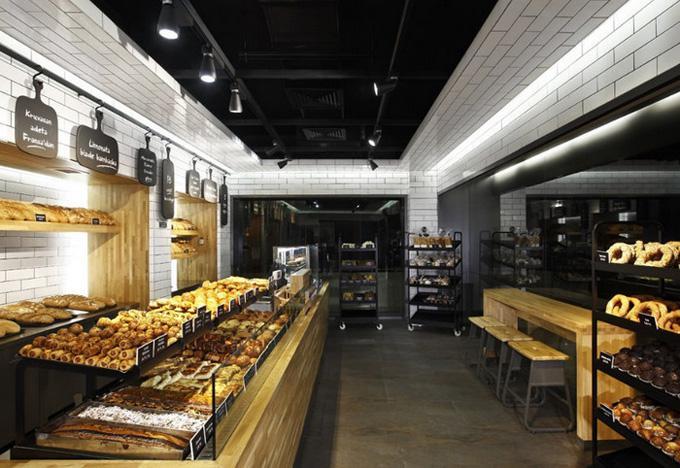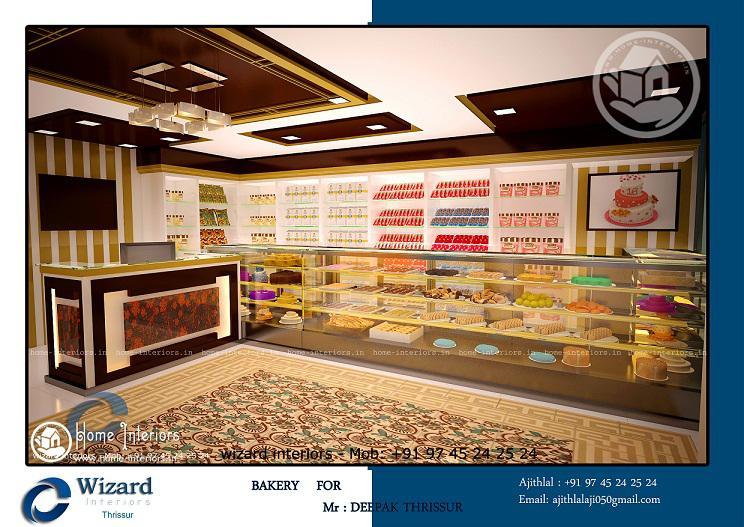The first image is the image on the left, the second image is the image on the right. Analyze the images presented: Is the assertion "The bakery in one image has white tile walls and uses black paddles for signs." valid? Answer yes or no. Yes. 